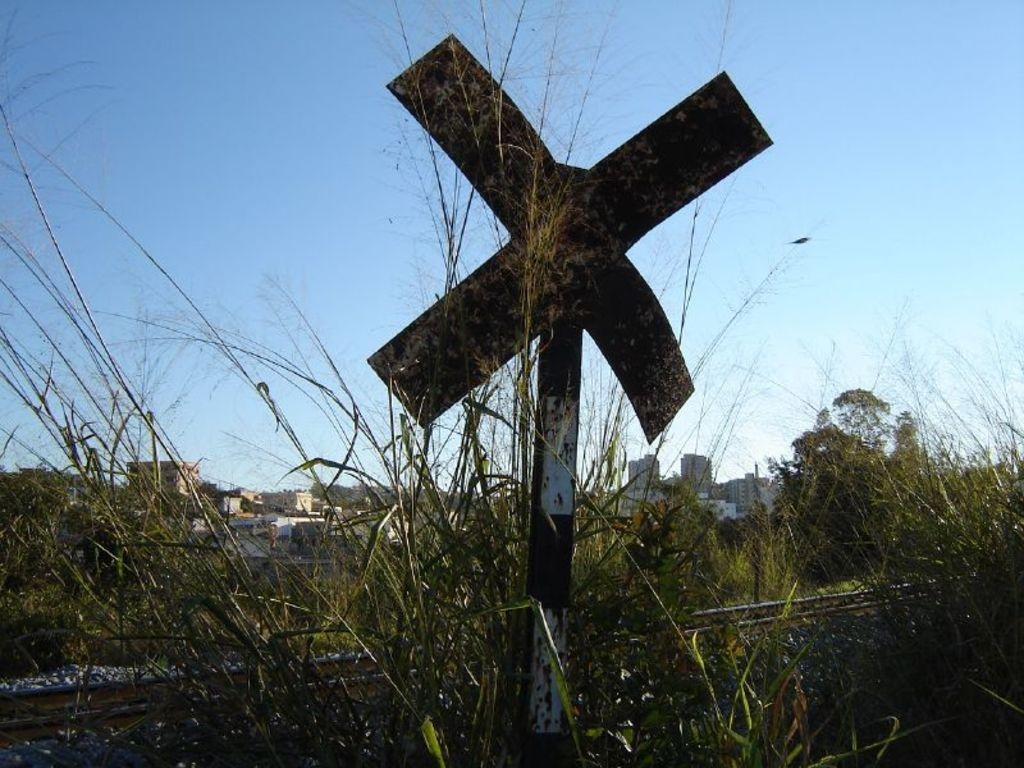What is the main feature in the center of the image? There is a railway track in the center of the image. What type of terrain is visible in the image? Stones and grass are present in the image. What is attached to the pole in the image? There is an object on the pole. What can be seen in the background of the image? The sky, buildings, and plants are visible in the background of the image. How does the comfort of the railway track affect the circle in the image? There is no circle present in the image, and the comfort of the railway track does not have any effect on the image. 